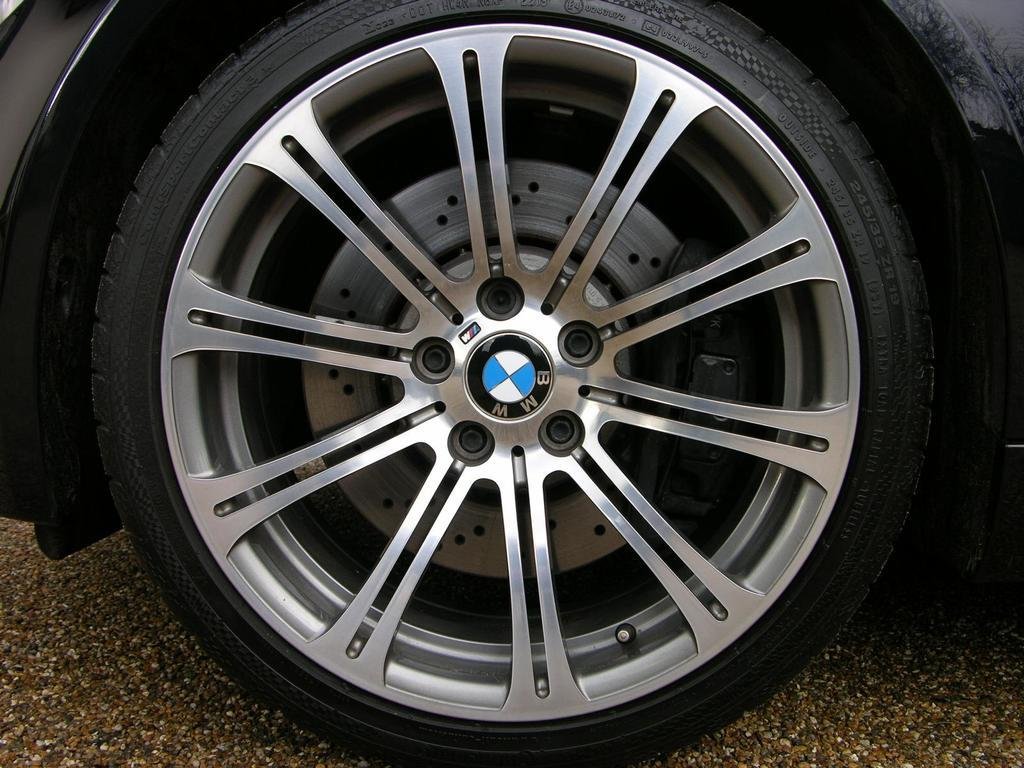What object from a vehicle can be seen in the image? There is a tyre of a vehicle in the image. Where is the tyre located? The tyre is placed on the road. What type of account is being discussed in the image? There is no account being discussed in the image; it features a tyre placed on the road. 